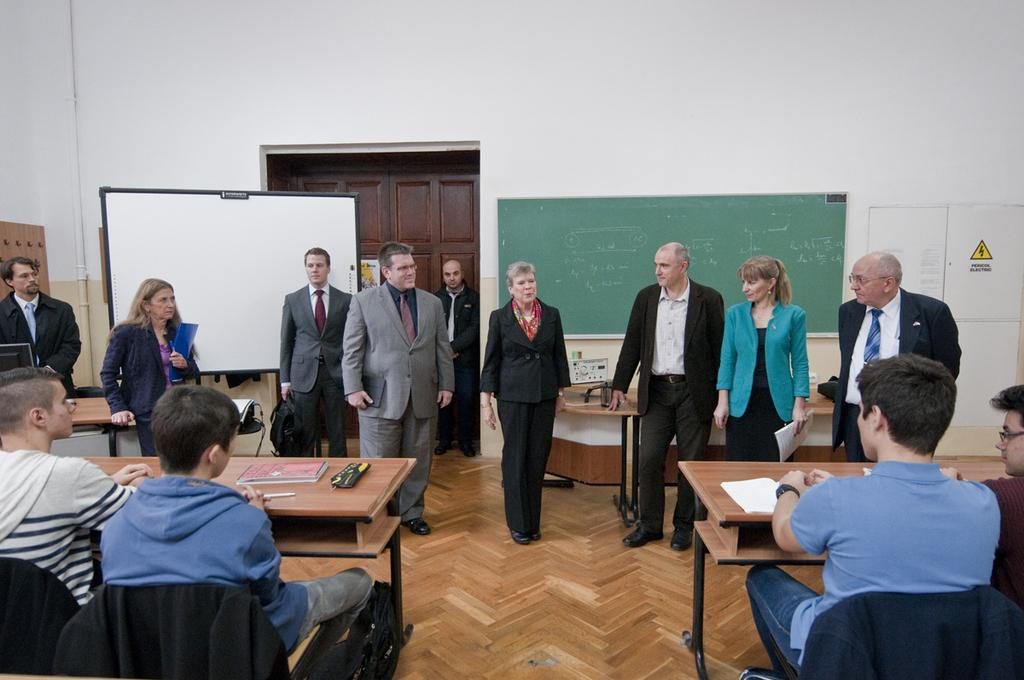What type of space is depicted in the image? There is a hall in the image. What is one feature of the hall that can be seen? There is a door in the image. What object is present on the wall in the image? There is a board in the image. What are the people in the image doing? There are people sitting in the image. What type of furniture is present in the hall? There are tables and chairs in the image. How many people are sitting on chairs in the image? Four people are sitting on chairs. What type of slope can be seen in the image? There is no slope present in the image. How many boys are sitting on chairs in the image? The provided facts do not mention the gender of the people sitting on chairs, so it cannot be determined if any of them are boys. 